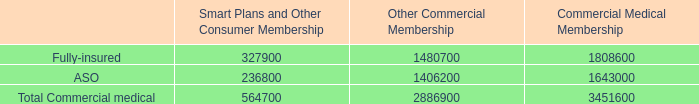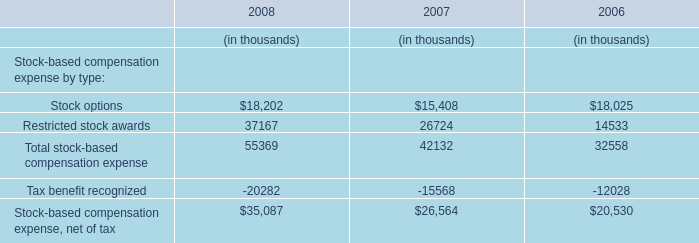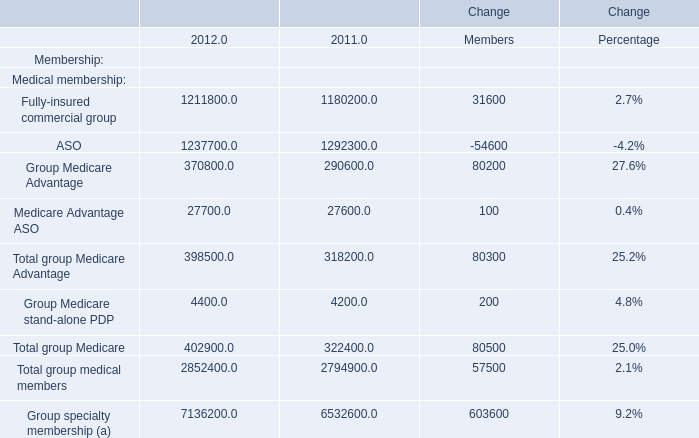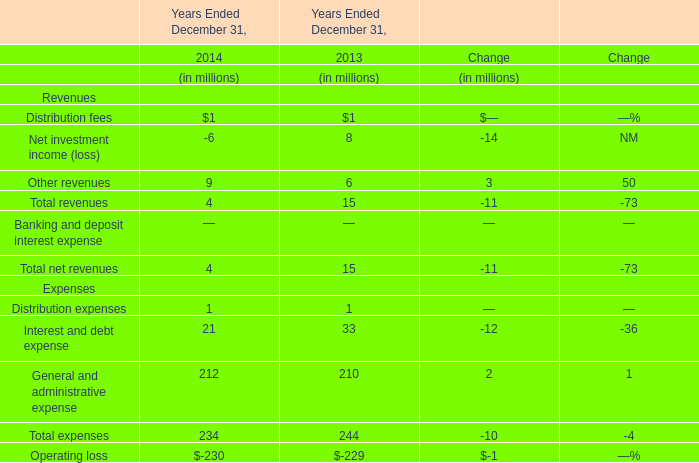Does ASO keeps increasing each year between 2011and 2012? 
Answer: no. 